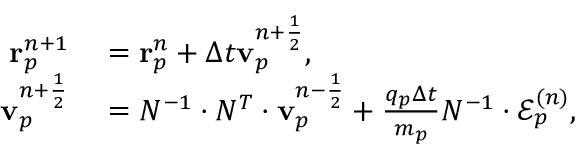Convert formula to latex. <formula><loc_0><loc_0><loc_500><loc_500>\begin{array} { r l } { r _ { p } ^ { n + 1 } } & = r _ { p } ^ { n } + \Delta t v _ { p } ^ { n + \frac { 1 } { 2 } } , } \\ { v _ { p } ^ { n + \frac { 1 } { 2 } } } & = N ^ { - 1 } \cdot N ^ { T } \cdot v _ { p } ^ { n - \frac { 1 } { 2 } } + \frac { q _ { p } \Delta t } { m _ { p } } N ^ { - 1 } \cdot \mathcal { E } _ { p } ^ { ( n ) } , } \end{array}</formula> 